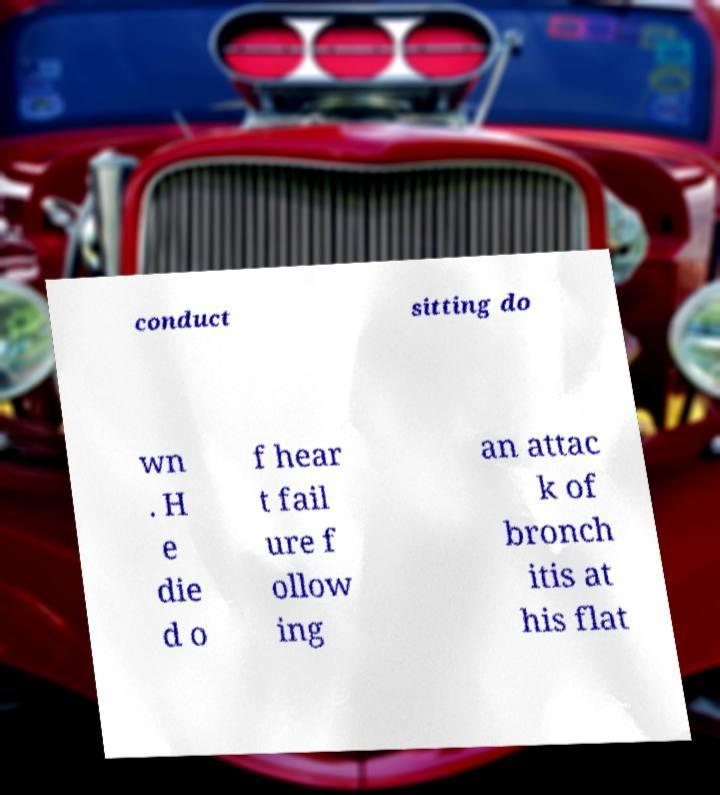Could you extract and type out the text from this image? conduct sitting do wn . H e die d o f hear t fail ure f ollow ing an attac k of bronch itis at his flat 